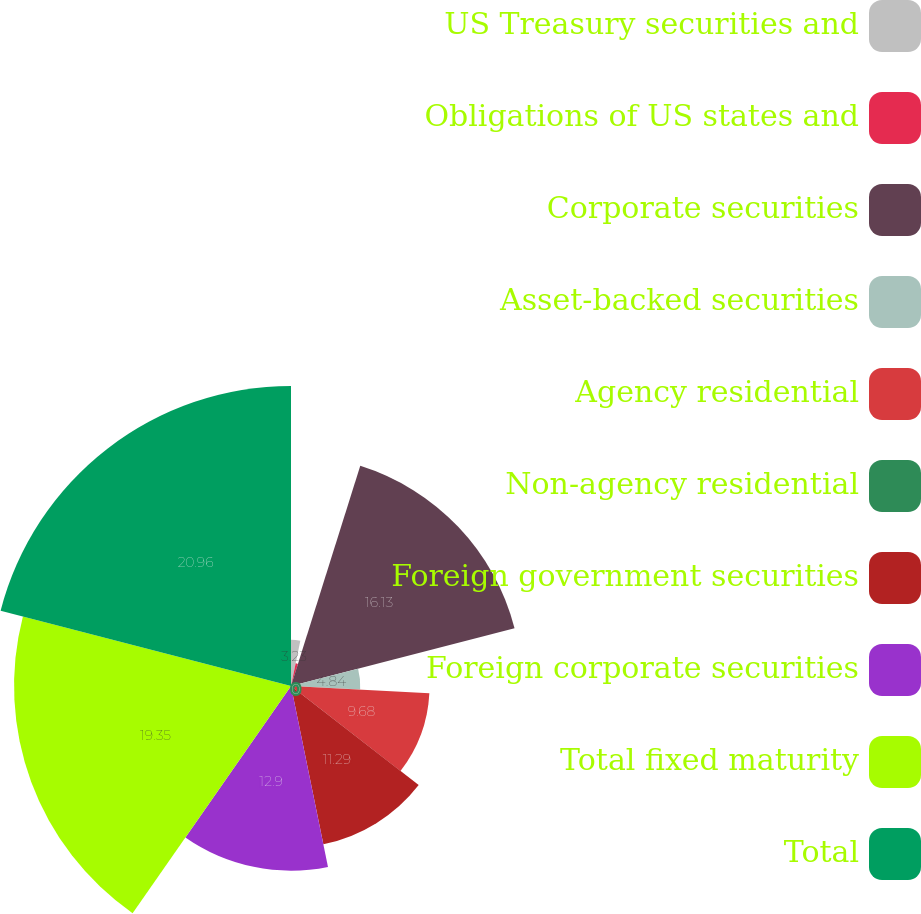<chart> <loc_0><loc_0><loc_500><loc_500><pie_chart><fcel>US Treasury securities and<fcel>Obligations of US states and<fcel>Corporate securities<fcel>Asset-backed securities<fcel>Agency residential<fcel>Non-agency residential<fcel>Foreign government securities<fcel>Foreign corporate securities<fcel>Total fixed maturity<fcel>Total<nl><fcel>3.23%<fcel>1.62%<fcel>16.13%<fcel>4.84%<fcel>9.68%<fcel>0.0%<fcel>11.29%<fcel>12.9%<fcel>19.35%<fcel>20.96%<nl></chart> 